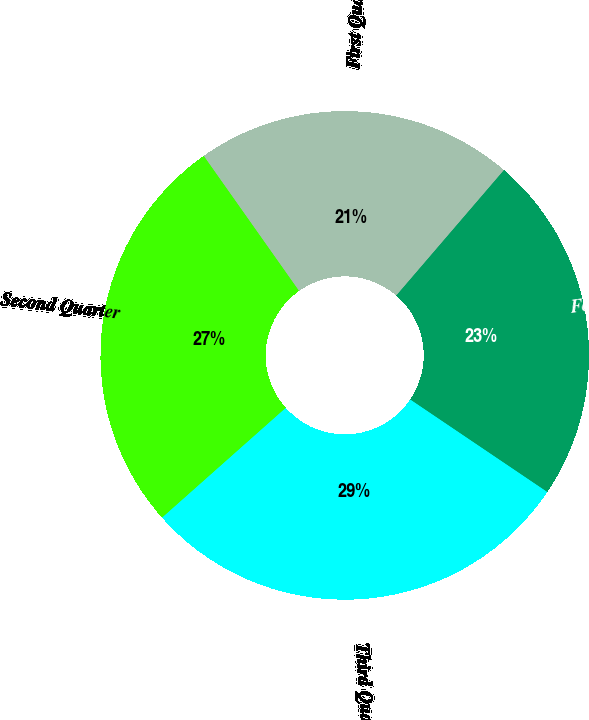Convert chart. <chart><loc_0><loc_0><loc_500><loc_500><pie_chart><fcel>Fourth Quarter<fcel>Third Quarter<fcel>Second Quarter<fcel>First Quarter<nl><fcel>23.16%<fcel>29.0%<fcel>26.77%<fcel>21.07%<nl></chart> 